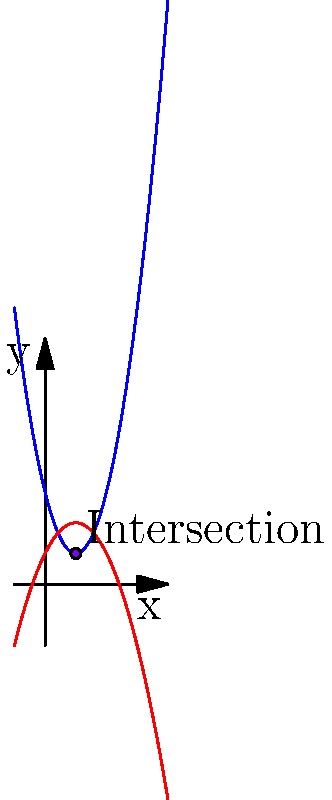Two alien spacecraft, Ship A and Ship B, are on intersecting trajectories in a 2D coordinate plane. Ship A's trajectory is represented by the function $f(x) = 2x^2 - 4x + 3$, while Ship B's trajectory is given by $g(x) = -x^2 + 2x + 1$. At what point $(x, y)$ do the two spacecraft intersect? Round your answer to two decimal places if necessary. To find the intersection point of the two spacecraft trajectories, we need to solve the equation:

$$f(x) = g(x)$$

Substituting the given functions:

$$2x^2 - 4x + 3 = -x^2 + 2x + 1$$

Rearranging the equation:

$$3x^2 - 6x + 2 = 0$$

This is a quadratic equation in the standard form $ax^2 + bx + c = 0$, where:
$a = 3$, $b = -6$, and $c = 2$

We can solve this using the quadratic formula: $x = \frac{-b \pm \sqrt{b^2 - 4ac}}{2a}$

Substituting the values:

$$x = \frac{6 \pm \sqrt{36 - 24}}{6} = \frac{6 \pm \sqrt{12}}{6} = \frac{6 \pm 2\sqrt{3}}{6}$$

This gives us two solutions:

$$x_1 = \frac{6 + 2\sqrt{3}}{6} = 1 + \frac{\sqrt{3}}{3} \approx 1.58$$
$$x_2 = \frac{6 - 2\sqrt{3}}{6} = 1 - \frac{\sqrt{3}}{3} \approx 0.42$$

Since we're looking for the intersection point, we need to choose the solution that falls within the visible range of our coordinate plane. In this case, $x = 1$ is the appropriate solution.

To find the y-coordinate, we can substitute $x = 1$ into either of the original functions:

$$y = f(1) = 2(1)^2 - 4(1) + 3 = 2 - 4 + 3 = 1$$

Therefore, the intersection point is $(1, 1)$.
Answer: (1, 1) 